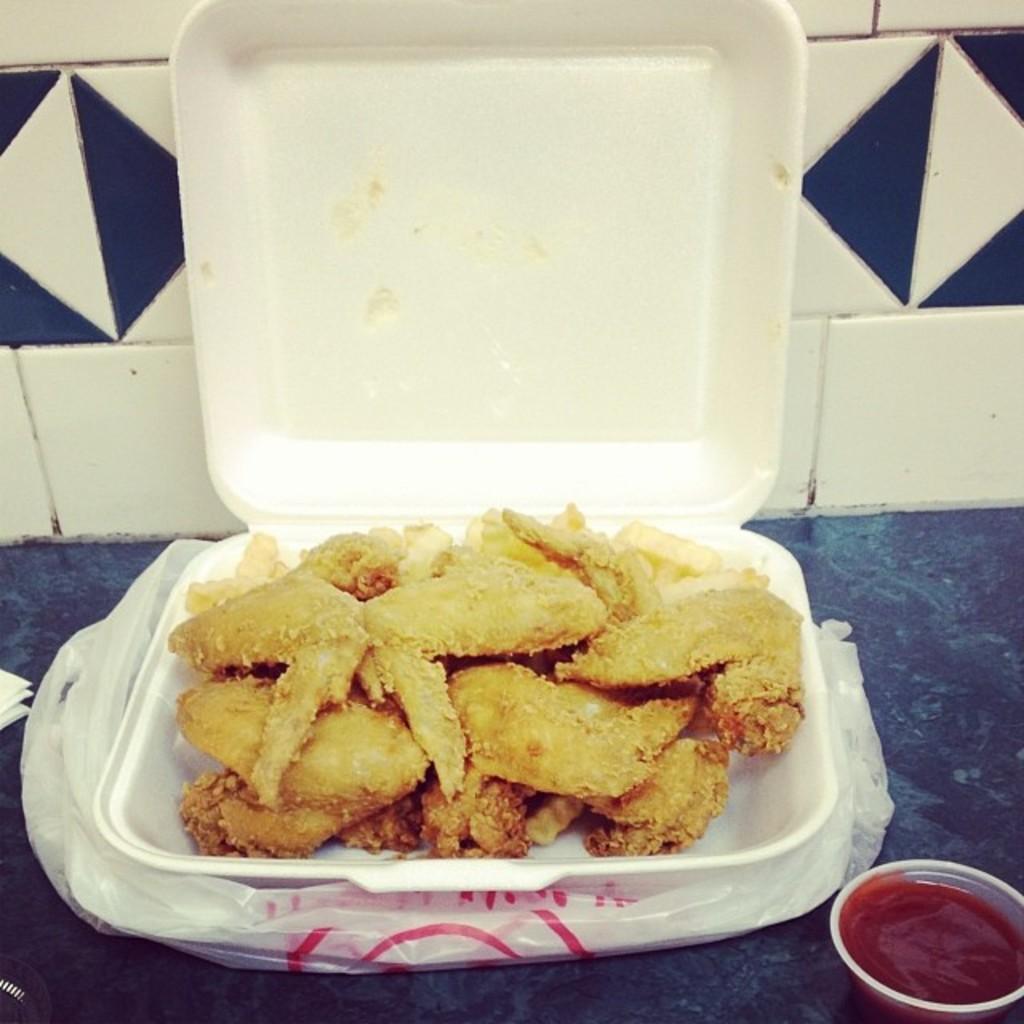How would you summarize this image in a sentence or two? In this picture we can see food in a box and the box is on the polythene cover. In the bottom right corner of the image, there is red sauce in the bowl. On the left side of the image, there are some objects. Behind the box, there is a wall. 